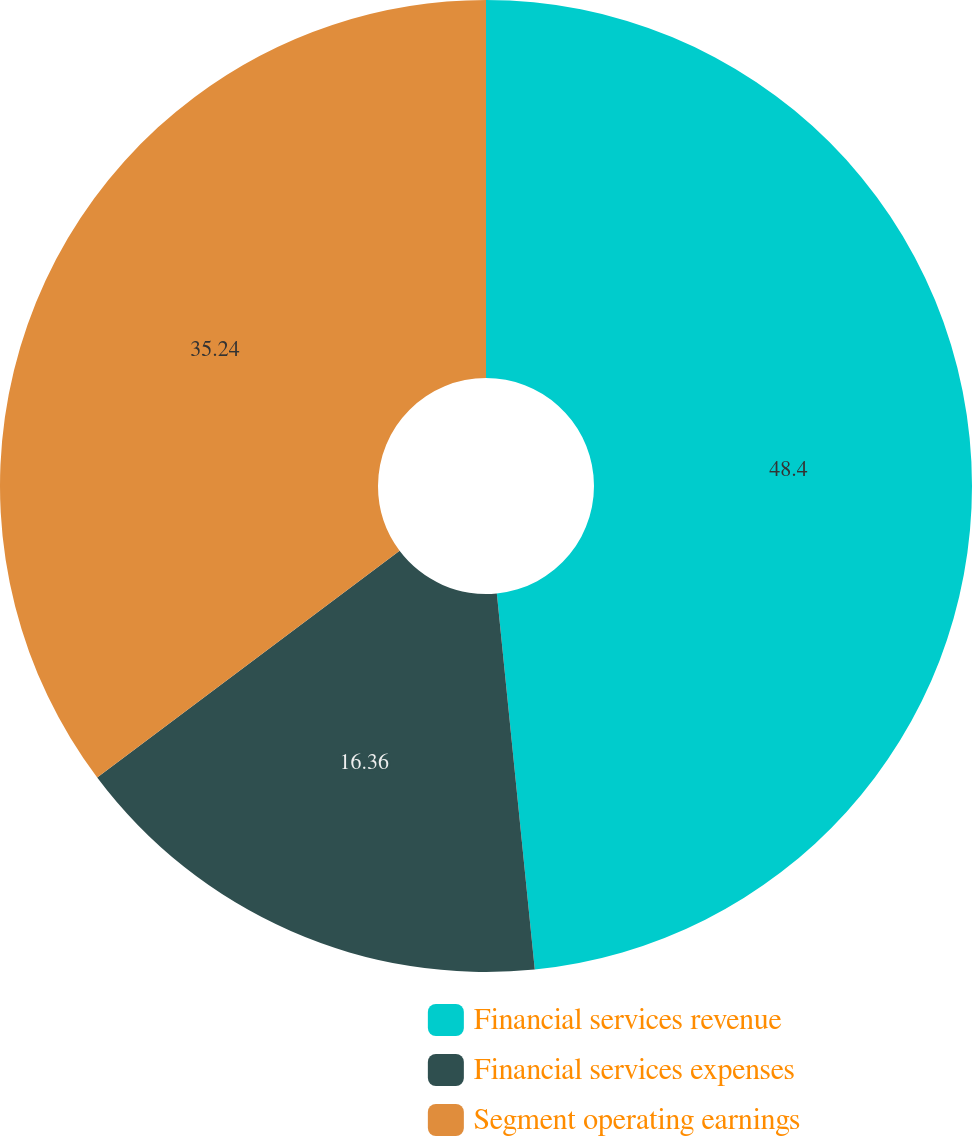Convert chart. <chart><loc_0><loc_0><loc_500><loc_500><pie_chart><fcel>Financial services revenue<fcel>Financial services expenses<fcel>Segment operating earnings<nl><fcel>48.4%<fcel>16.36%<fcel>35.24%<nl></chart> 